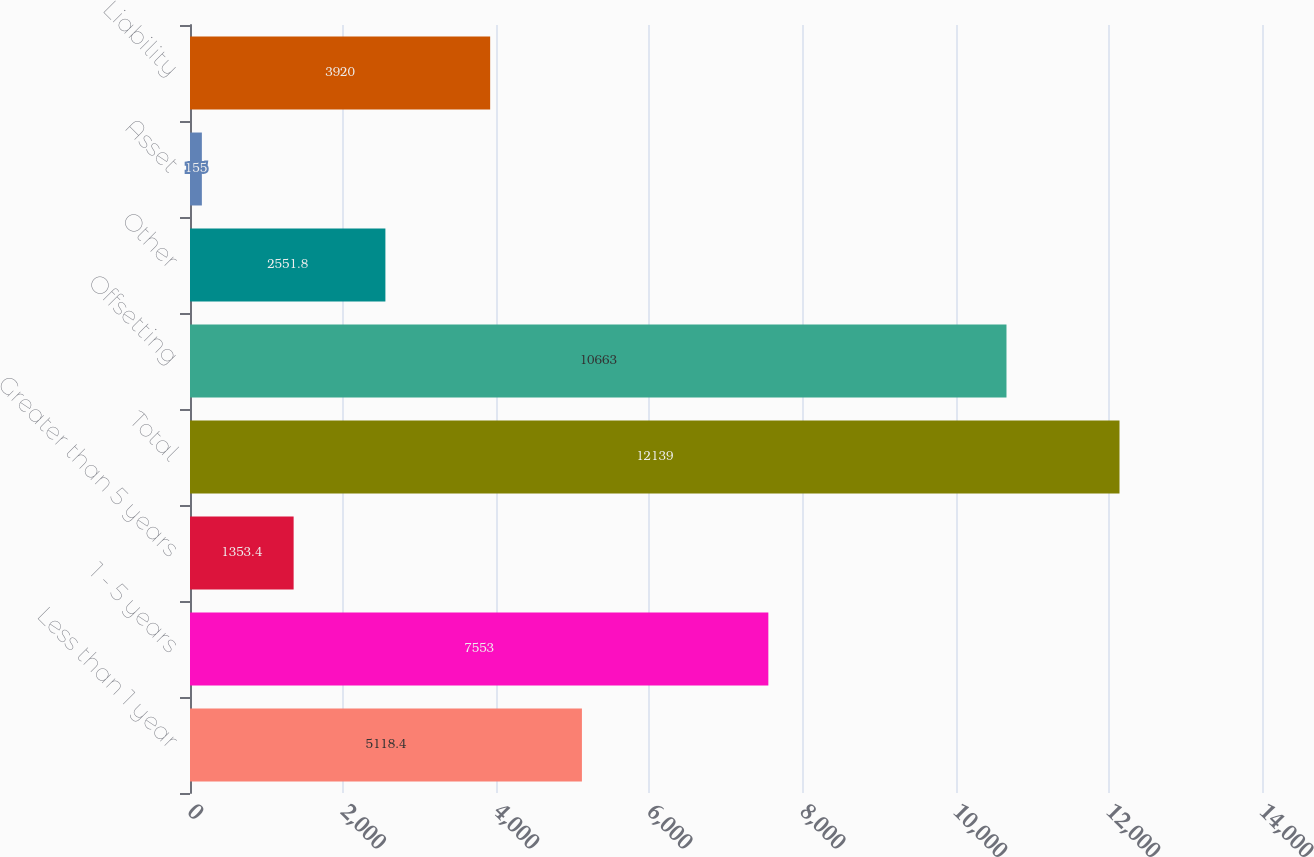Convert chart to OTSL. <chart><loc_0><loc_0><loc_500><loc_500><bar_chart><fcel>Less than 1 year<fcel>1 - 5 years<fcel>Greater than 5 years<fcel>Total<fcel>Offsetting<fcel>Other<fcel>Asset<fcel>Liability<nl><fcel>5118.4<fcel>7553<fcel>1353.4<fcel>12139<fcel>10663<fcel>2551.8<fcel>155<fcel>3920<nl></chart> 